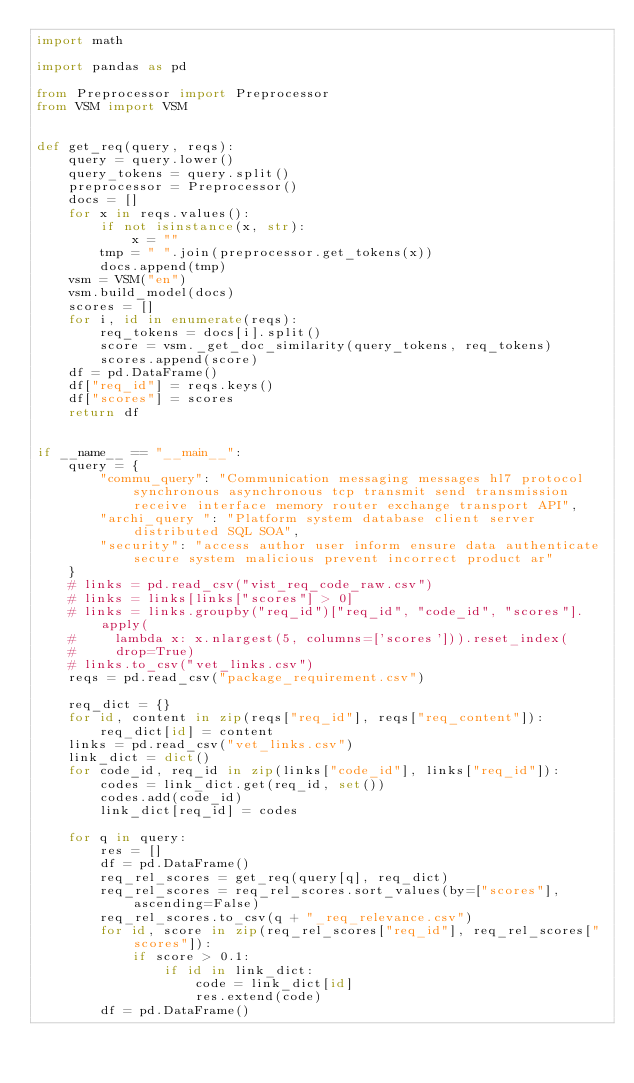Convert code to text. <code><loc_0><loc_0><loc_500><loc_500><_Python_>import math

import pandas as pd

from Preprocessor import Preprocessor
from VSM import VSM


def get_req(query, reqs):
    query = query.lower()
    query_tokens = query.split()
    preprocessor = Preprocessor()
    docs = []
    for x in reqs.values():
        if not isinstance(x, str):
            x = ""
        tmp = " ".join(preprocessor.get_tokens(x))
        docs.append(tmp)
    vsm = VSM("en")
    vsm.build_model(docs)
    scores = []
    for i, id in enumerate(reqs):
        req_tokens = docs[i].split()
        score = vsm._get_doc_similarity(query_tokens, req_tokens)
        scores.append(score)
    df = pd.DataFrame()
    df["req_id"] = reqs.keys()
    df["scores"] = scores
    return df


if __name__ == "__main__":
    query = {
        "commu_query": "Communication messaging messages hl7 protocol synchronous asynchronous tcp transmit send transmission receive interface memory router exchange transport API",
        "archi_query ": "Platform system database client server distributed SQL SOA",
        "security": "access author user inform ensure data authenticate secure system malicious prevent incorrect product ar"
    }
    # links = pd.read_csv("vist_req_code_raw.csv")
    # links = links[links["scores"] > 0]
    # links = links.groupby("req_id")["req_id", "code_id", "scores"].apply(
    #     lambda x: x.nlargest(5, columns=['scores'])).reset_index(
    #     drop=True)
    # links.to_csv("vet_links.csv")
    reqs = pd.read_csv("package_requirement.csv")

    req_dict = {}
    for id, content in zip(reqs["req_id"], reqs["req_content"]):
        req_dict[id] = content
    links = pd.read_csv("vet_links.csv")
    link_dict = dict()
    for code_id, req_id in zip(links["code_id"], links["req_id"]):
        codes = link_dict.get(req_id, set())
        codes.add(code_id)
        link_dict[req_id] = codes

    for q in query:
        res = []
        df = pd.DataFrame()
        req_rel_scores = get_req(query[q], req_dict)
        req_rel_scores = req_rel_scores.sort_values(by=["scores"], ascending=False)
        req_rel_scores.to_csv(q + "_req_relevance.csv")
        for id, score in zip(req_rel_scores["req_id"], req_rel_scores["scores"]):
            if score > 0.1:
                if id in link_dict:
                    code = link_dict[id]
                    res.extend(code)
        df = pd.DataFrame()</code> 